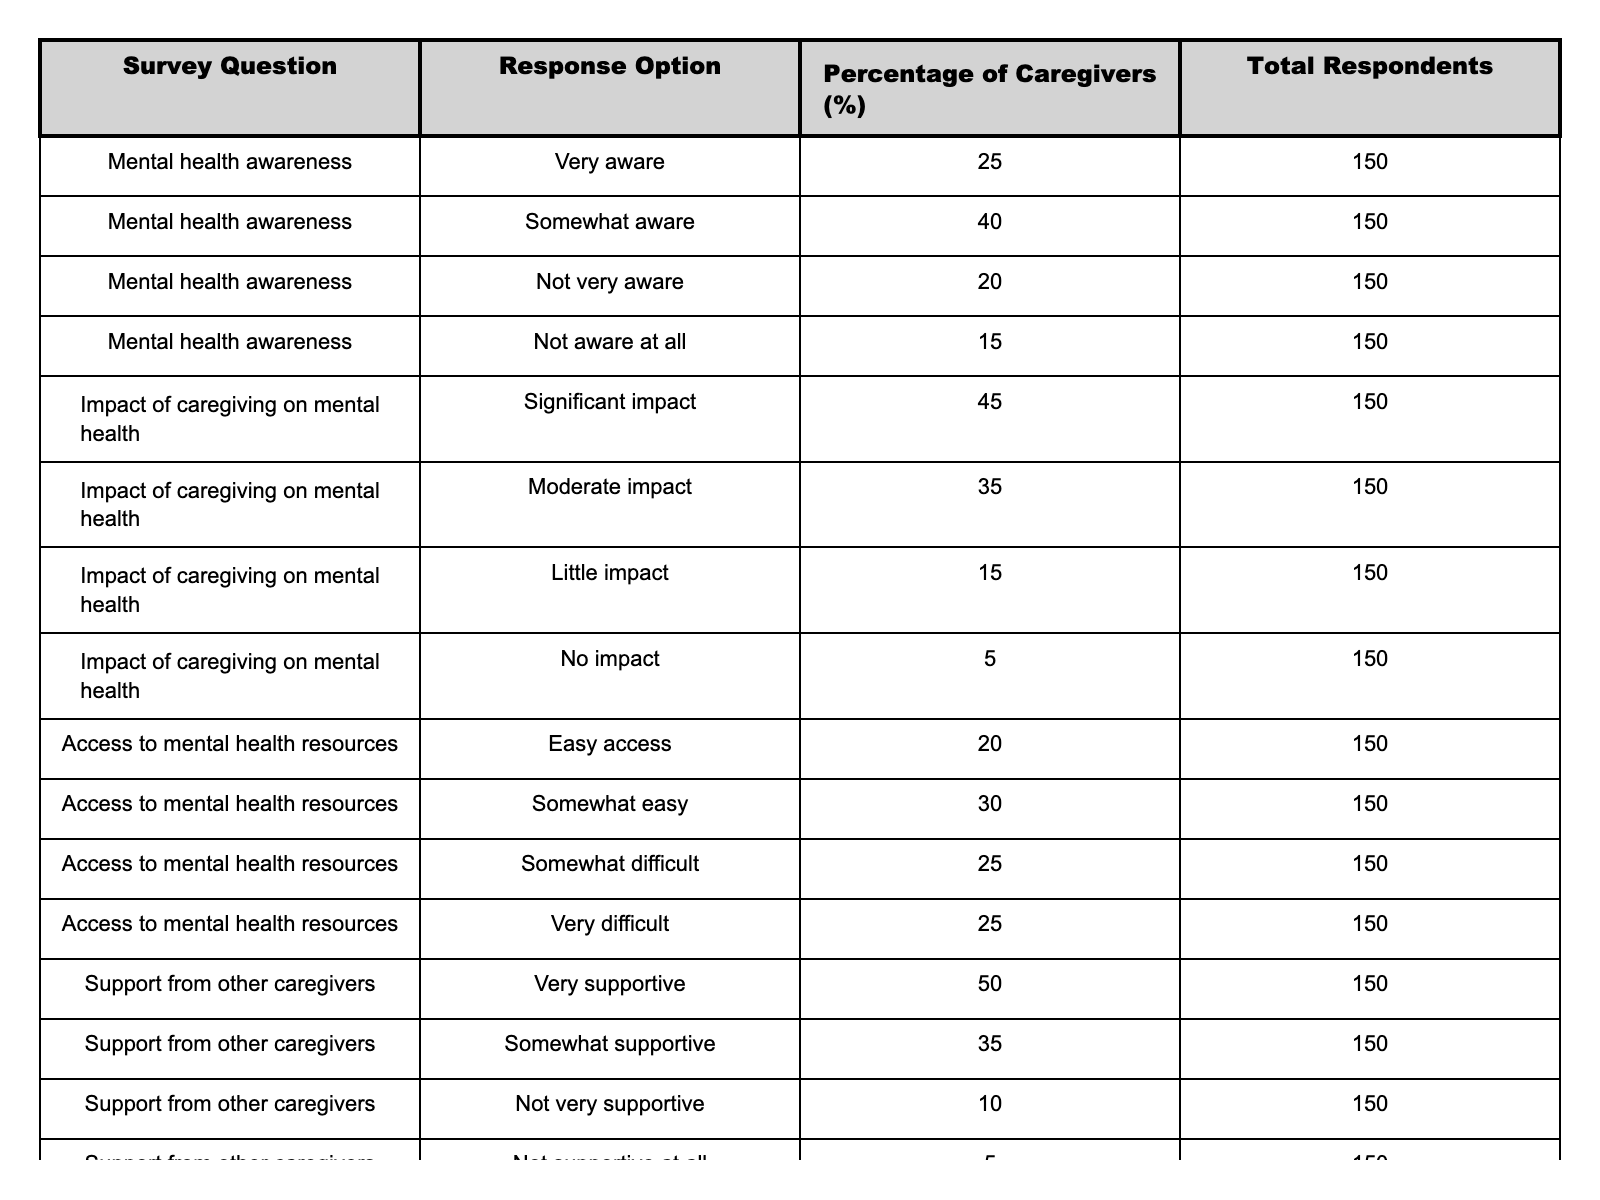What percentage of caregivers feel very aware of mental health issues? According to the table, 25% of caregivers indicated they are very aware of mental health issues.
Answer: 25% What is the combined percentage of caregivers who feel either not very aware or not aware at all of mental health issues? Adding the percentages for "Not very aware" (20%) and "Not aware at all" (15%) gives a total of 35% (20% + 15%).
Answer: 35% Do more caregivers report a significant impact of caregiving on mental health than those who report no impact? Yes, 45% of caregivers report a significant impact, while only 5% report no impact, which shows a clear majority reporting significant impact.
Answer: Yes What percentage of caregivers feel very supportive from other caregivers? The table indicates that 50% of caregivers feel very supportive from other caregivers.
Answer: 50% What is the percentage difference between caregivers who feel somewhat supportive and those who are not supportive at all? The percentage of caregivers who feel somewhat supportive is 35%, and those who feel not supportive at all is 5%, resulting in a difference of 30% (35% - 5%).
Answer: 30% What percentage of caregivers have easy or somewhat easy access to mental health resources? To find this, we add the percentages of "Easy access" (20%) and "Somewhat easy" (30%), resulting in a total of 50% (20% + 30%).
Answer: 50% Is it true that the majority of caregivers report some level of support from other caregivers? Yes, 50% report being very supportive and 35% somewhat supportive, adding up to 85%, which indicates a majority.
Answer: Yes Which category of mental health awareness has the least percentage of caregivers? The category with the least percentage of caregivers is "Not aware at all," with 15%.
Answer: 15% What percentage of caregivers believe they have a moderate impact on their mental health due to caregiving? According to the table, 35% of caregivers report a moderate impact on their mental health.
Answer: 35% What is the total percentage of caregivers who find accessing mental health resources challenging (somewhat difficult and very difficult)? The sum of "Somewhat difficult" (25%) and "Very difficult" (25%) is 50% (25% + 25%).
Answer: 50% 